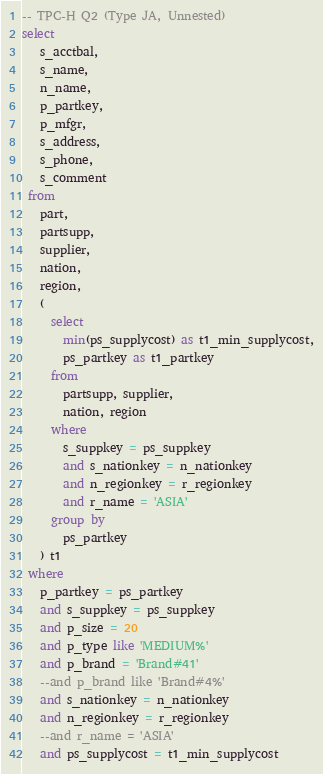Convert code to text. <code><loc_0><loc_0><loc_500><loc_500><_SQL_>-- TPC-H Q2 (Type JA, Unnested)
select
   s_acctbal,
   s_name,
   n_name,
   p_partkey,
   p_mfgr,
   s_address,
   s_phone,
   s_comment
 from
   part,
   partsupp,
   supplier,
   nation,
   region,
   (
     select
       min(ps_supplycost) as t1_min_supplycost,
       ps_partkey as t1_partkey
     from
       partsupp, supplier,
       nation, region
     where
       s_suppkey = ps_suppkey
       and s_nationkey = n_nationkey
       and n_regionkey = r_regionkey
       and r_name = 'ASIA'
     group by
       ps_partkey
   ) t1
 where
   p_partkey = ps_partkey
   and s_suppkey = ps_suppkey
   and p_size = 20
   and p_type like 'MEDIUM%'
   and p_brand = 'Brand#41'
   --and p_brand like 'Brand#4%'
   and s_nationkey = n_nationkey
   and n_regionkey = r_regionkey
   --and r_name = 'ASIA'
   and ps_supplycost = t1_min_supplycost</code> 